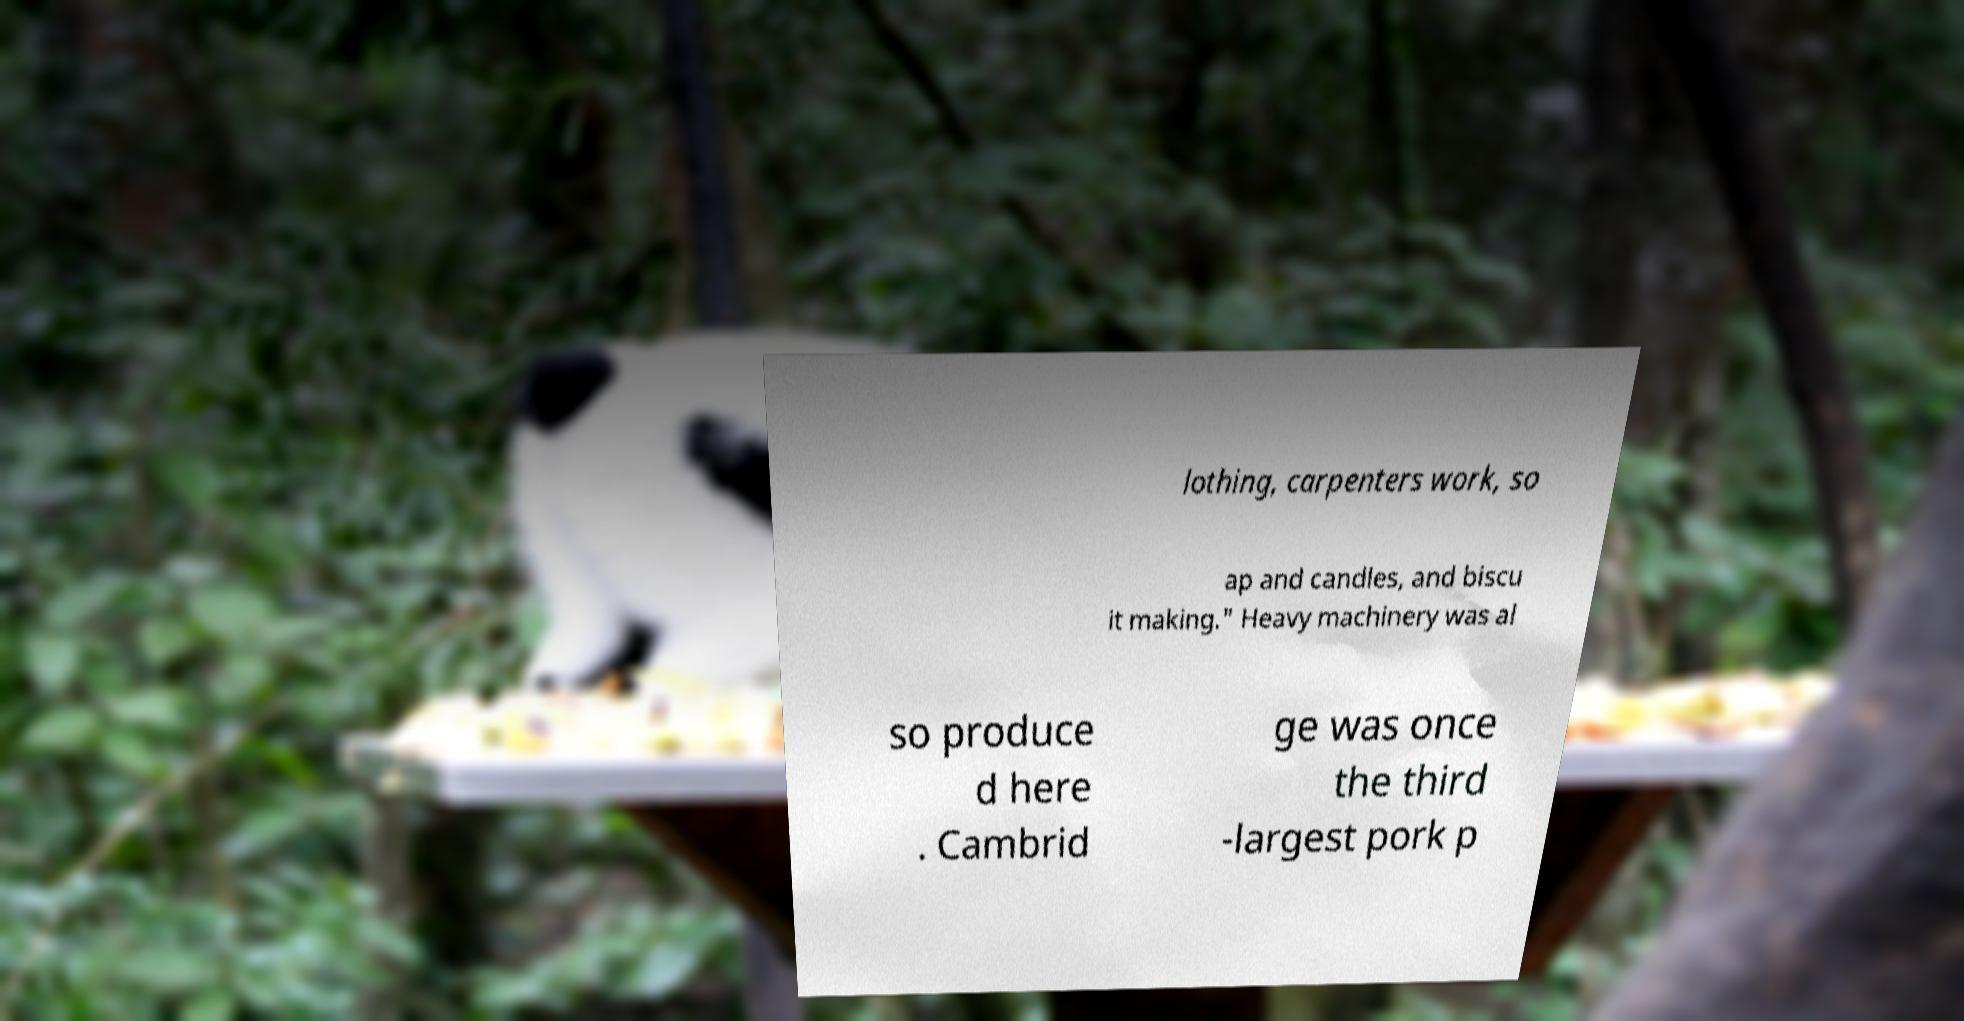I need the written content from this picture converted into text. Can you do that? lothing, carpenters work, so ap and candles, and biscu it making." Heavy machinery was al so produce d here . Cambrid ge was once the third -largest pork p 